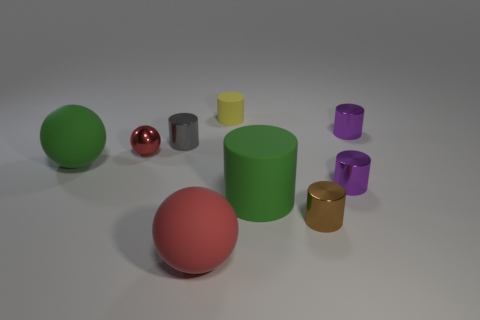Does the big green object that is to the left of the tiny red shiny thing have the same material as the green thing to the right of the tiny rubber object?
Provide a short and direct response. Yes. What number of blue spheres are there?
Offer a terse response. 0. How many tiny red metallic things have the same shape as the tiny matte thing?
Make the answer very short. 0. Does the brown object have the same shape as the tiny gray object?
Keep it short and to the point. Yes. How big is the green rubber sphere?
Your response must be concise. Large. What number of rubber cylinders are the same size as the shiny sphere?
Your answer should be compact. 1. There is a ball in front of the tiny brown cylinder; is it the same size as the purple object that is in front of the small gray shiny cylinder?
Make the answer very short. No. What shape is the purple thing behind the green ball?
Provide a succinct answer. Cylinder. What material is the big ball left of the metal sphere that is left of the small yellow cylinder made of?
Your answer should be compact. Rubber. Is there a cylinder of the same color as the small metallic sphere?
Your response must be concise. No. 